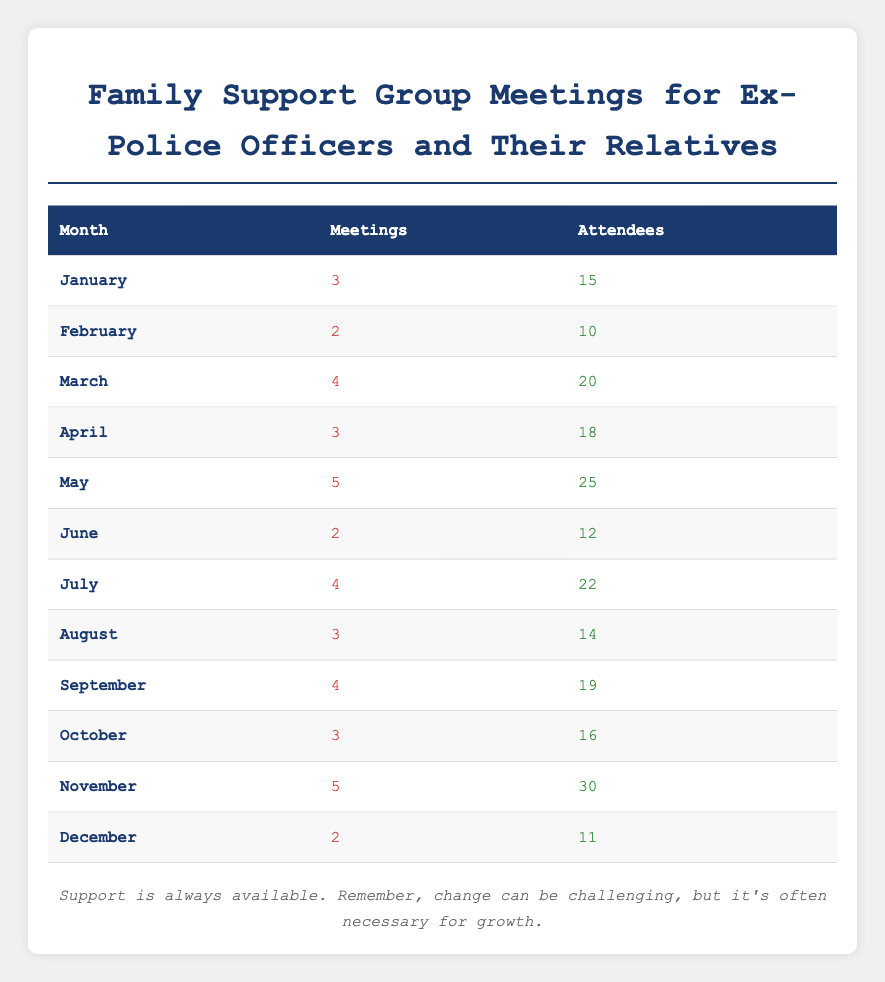What month had the highest number of meetings? By reviewing the "Meetings" column, I can see that May has the highest value with 5 meetings.
Answer: May How many attendees were there in June? Looking at the "Attendees" column for June, the table shows that there were 12 attendees.
Answer: 12 What is the total number of meetings held from January to December? To find the total, I add the meetings from each month: 3 + 2 + 4 + 3 + 5 + 2 + 4 + 3 + 4 + 3 + 5 + 2 = 46.
Answer: 46 Did November have more than 25 attendees? In the table, November shows 30 attendees, which is indeed more than 25.
Answer: Yes What is the average number of attendees across all months? First, I sum the total attendees: 15 + 10 + 20 + 18 + 25 + 12 + 22 + 14 + 19 + 16 + 30 + 11 =  292. Then, I divide by 12 months: 292 / 12 = 24.33.
Answer: 24.33 How many months had 4 or more meetings? From the "Meetings" column, I can count that 4 months had 4 or more meetings: March, May, July, and November.
Answer: 4 Which month had the least number of attendees? Examining the "Attendees" column, I see February has the lowest number with 10 attendees.
Answer: February If we exclude the months of January and December, what is the average number of attendees for the remaining months? First, we calculate the total attendance for February to November: 10 + 20 + 18 + 25 + 12 + 22 + 14 + 19 + 16 + 30 =  216. The number of months is 10, so I divide 216 by 10 to get an average of 21.6.
Answer: 21.6 Was there a month where the number of meetings equaled the number of attendees? By checking both columns, I can see that there is no month where the "Meetings" number is equal to the "Attendees" number.
Answer: No 